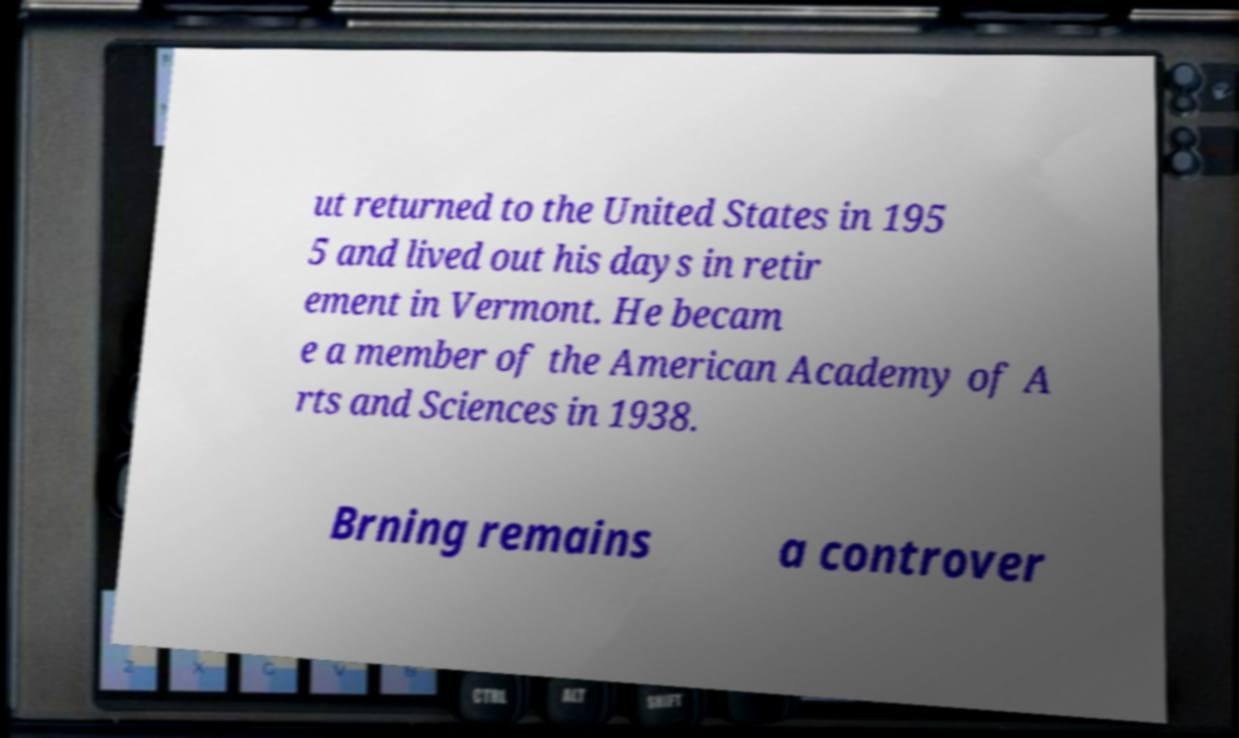For documentation purposes, I need the text within this image transcribed. Could you provide that? ut returned to the United States in 195 5 and lived out his days in retir ement in Vermont. He becam e a member of the American Academy of A rts and Sciences in 1938. Brning remains a controver 